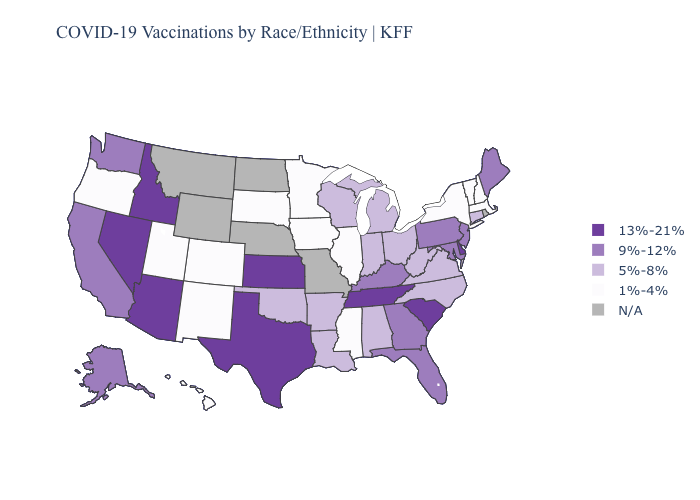What is the lowest value in the West?
Write a very short answer. 1%-4%. Name the states that have a value in the range 9%-12%?
Quick response, please. Alaska, California, Florida, Georgia, Kentucky, Maine, Maryland, New Jersey, Pennsylvania, Washington. Does Vermont have the lowest value in the USA?
Short answer required. Yes. What is the lowest value in the USA?
Quick response, please. 1%-4%. Name the states that have a value in the range 1%-4%?
Short answer required. Colorado, Hawaii, Illinois, Iowa, Massachusetts, Minnesota, Mississippi, New Hampshire, New Mexico, New York, Oregon, South Dakota, Utah, Vermont. Name the states that have a value in the range 1%-4%?
Concise answer only. Colorado, Hawaii, Illinois, Iowa, Massachusetts, Minnesota, Mississippi, New Hampshire, New Mexico, New York, Oregon, South Dakota, Utah, Vermont. How many symbols are there in the legend?
Write a very short answer. 5. Name the states that have a value in the range 9%-12%?
Quick response, please. Alaska, California, Florida, Georgia, Kentucky, Maine, Maryland, New Jersey, Pennsylvania, Washington. Among the states that border Nebraska , which have the highest value?
Concise answer only. Kansas. Name the states that have a value in the range N/A?
Concise answer only. Missouri, Montana, Nebraska, North Dakota, Rhode Island, Wyoming. What is the value of Wyoming?
Write a very short answer. N/A. Name the states that have a value in the range 1%-4%?
Give a very brief answer. Colorado, Hawaii, Illinois, Iowa, Massachusetts, Minnesota, Mississippi, New Hampshire, New Mexico, New York, Oregon, South Dakota, Utah, Vermont. Name the states that have a value in the range N/A?
Answer briefly. Missouri, Montana, Nebraska, North Dakota, Rhode Island, Wyoming. 